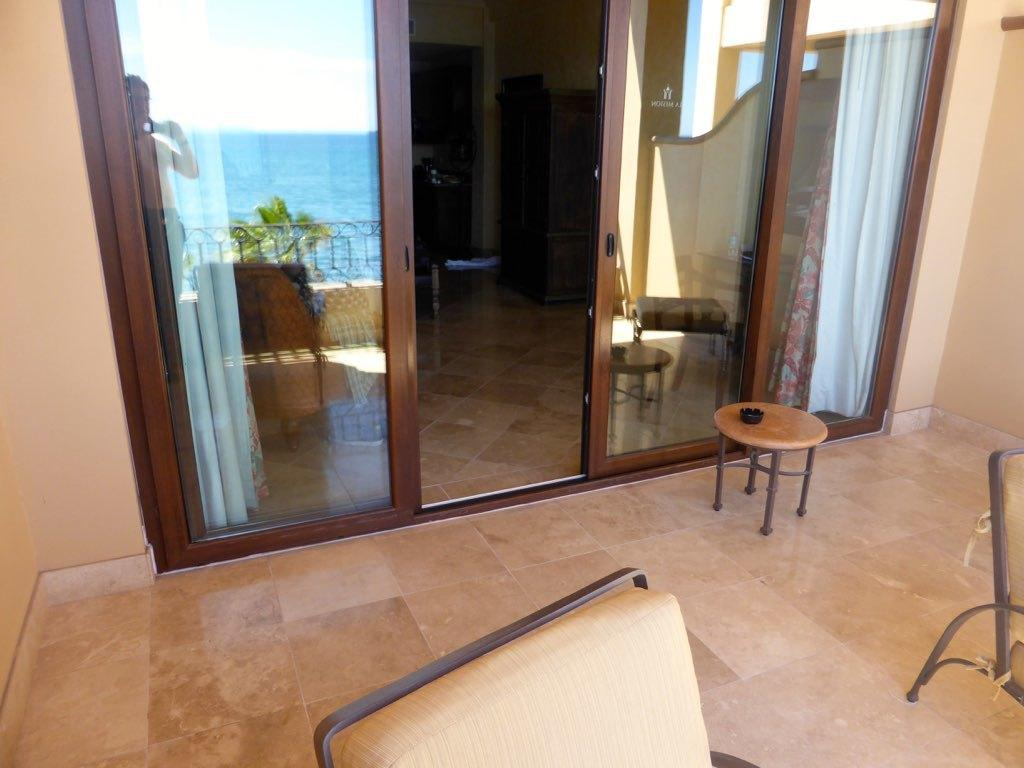What type of door is visible in the image? There is a glass door in the image. What is the woman in the image doing? The woman is standing and taking a photograph in the image. Where are the chairs located in the image? The chairs are on the right side of the image. How many fingers can be seen on the woman's hand in the image? The number of fingers on the woman's hand cannot be determined from the image, as her hand is not visible. What time of day is it in the image, based on the hour? The time of day cannot be determined from the image, as there is no clock or any indication of the hour. 